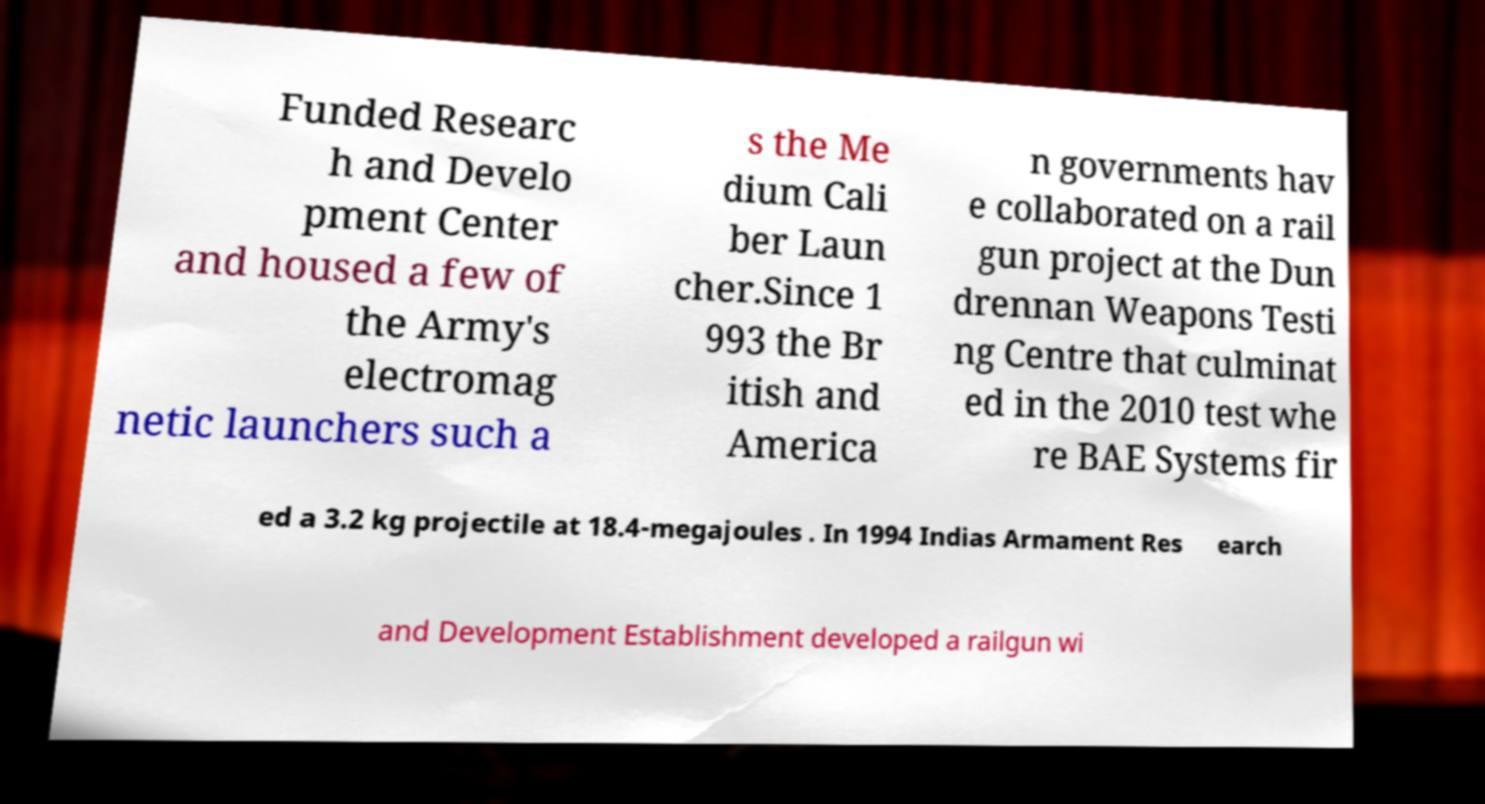Could you extract and type out the text from this image? Funded Researc h and Develo pment Center and housed a few of the Army's electromag netic launchers such a s the Me dium Cali ber Laun cher.Since 1 993 the Br itish and America n governments hav e collaborated on a rail gun project at the Dun drennan Weapons Testi ng Centre that culminat ed in the 2010 test whe re BAE Systems fir ed a 3.2 kg projectile at 18.4-megajoules . In 1994 Indias Armament Res earch and Development Establishment developed a railgun wi 